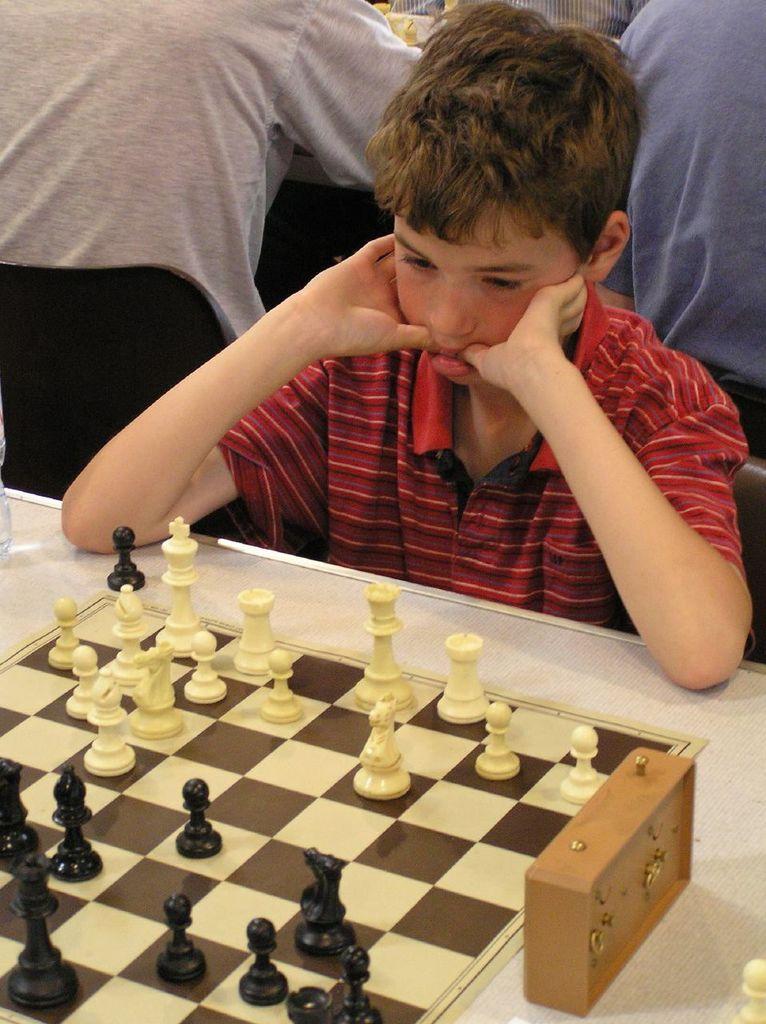Can you describe this image briefly? This picture describe about the small boy wearing red strip t- shirt sitting on the chair and seeing the chess board which is placed on the table and a timer watch beside the chess board, Behind we can see a two person sitting on chair wearing white t- shirt and blue t- shirt is playing the chess game. 